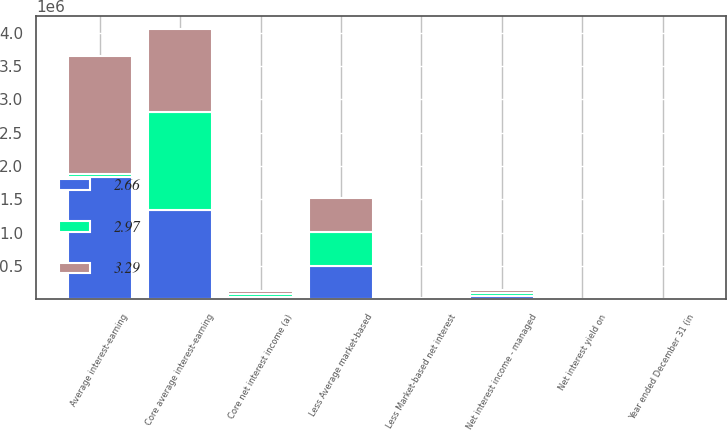<chart> <loc_0><loc_0><loc_500><loc_500><stacked_bar_chart><ecel><fcel>Year ended December 31 (in<fcel>Net interest income - managed<fcel>Less Market-based net interest<fcel>Core net interest income (a)<fcel>Average interest-earning<fcel>Less Average market-based<fcel>Core average interest-earning<fcel>Net interest yield on<nl><fcel>2.97<fcel>2013<fcel>44016<fcel>4979<fcel>39037<fcel>40890<fcel>504218<fcel>1.46601e+06<fcel>2.23<nl><fcel>2.66<fcel>2012<fcel>45653<fcel>5787<fcel>39866<fcel>1.84242e+06<fcel>499339<fcel>1.34308e+06<fcel>2.48<nl><fcel>3.29<fcel>2011<fcel>48219<fcel>7329<fcel>40890<fcel>1.76136e+06<fcel>519655<fcel>1.2417e+06<fcel>2.74<nl></chart> 